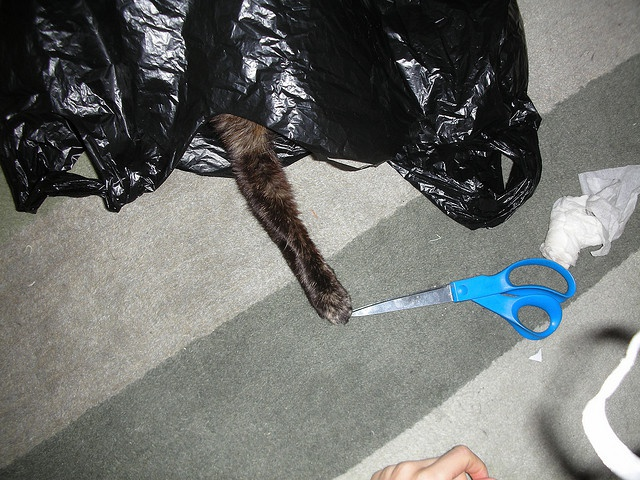Describe the objects in this image and their specific colors. I can see cat in black, gray, and maroon tones, scissors in black, lightblue, darkgray, and gray tones, and people in black, tan, lightgray, and darkgray tones in this image. 